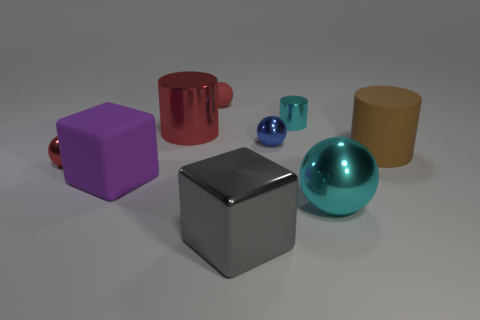Subtract all cyan cylinders. How many cylinders are left? 2 Subtract all green cubes. How many red balls are left? 2 Subtract all cubes. How many objects are left? 7 Subtract all purple blocks. How many blocks are left? 1 Subtract 2 balls. How many balls are left? 2 Add 8 red cylinders. How many red cylinders are left? 9 Add 1 tiny things. How many tiny things exist? 5 Subtract 0 yellow cubes. How many objects are left? 9 Subtract all green cylinders. Subtract all brown spheres. How many cylinders are left? 3 Subtract all red metal cylinders. Subtract all tiny purple metallic cylinders. How many objects are left? 8 